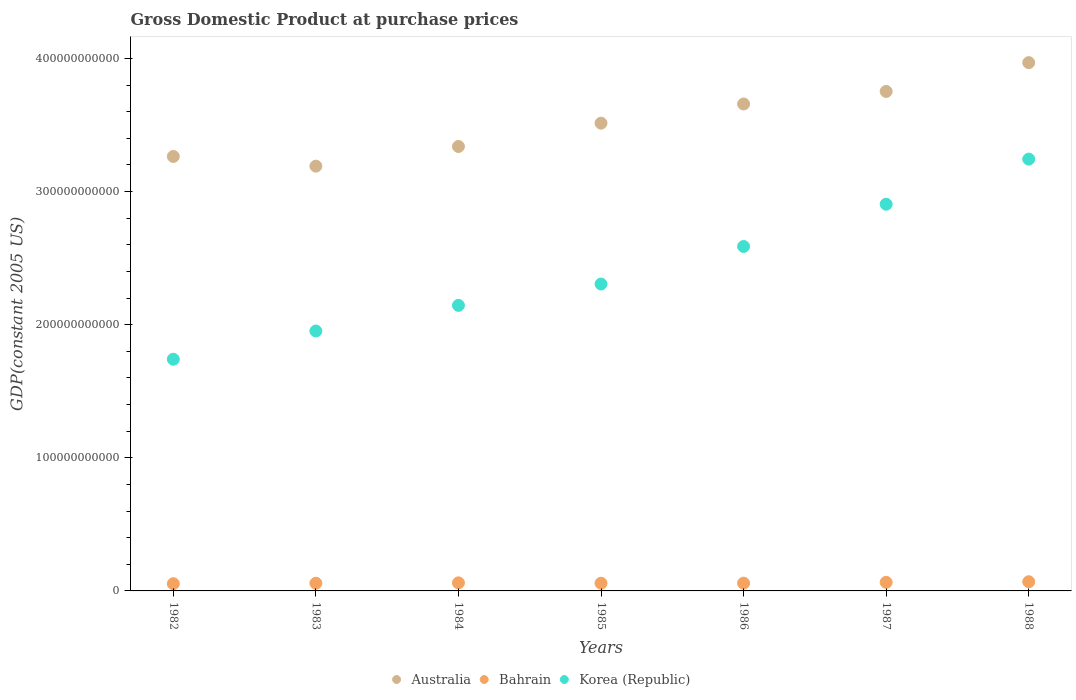Is the number of dotlines equal to the number of legend labels?
Offer a very short reply. Yes. What is the GDP at purchase prices in Australia in 1987?
Your answer should be very brief. 3.75e+11. Across all years, what is the maximum GDP at purchase prices in Australia?
Give a very brief answer. 3.97e+11. Across all years, what is the minimum GDP at purchase prices in Bahrain?
Your answer should be very brief. 5.43e+09. In which year was the GDP at purchase prices in Korea (Republic) maximum?
Keep it short and to the point. 1988. In which year was the GDP at purchase prices in Australia minimum?
Make the answer very short. 1983. What is the total GDP at purchase prices in Australia in the graph?
Your answer should be compact. 2.47e+12. What is the difference between the GDP at purchase prices in Bahrain in 1984 and that in 1988?
Provide a short and direct response. -8.39e+08. What is the difference between the GDP at purchase prices in Bahrain in 1985 and the GDP at purchase prices in Korea (Republic) in 1982?
Your answer should be very brief. -1.68e+11. What is the average GDP at purchase prices in Korea (Republic) per year?
Offer a terse response. 2.41e+11. In the year 1983, what is the difference between the GDP at purchase prices in Korea (Republic) and GDP at purchase prices in Bahrain?
Make the answer very short. 1.90e+11. What is the ratio of the GDP at purchase prices in Korea (Republic) in 1982 to that in 1985?
Your response must be concise. 0.76. Is the difference between the GDP at purchase prices in Korea (Republic) in 1983 and 1985 greater than the difference between the GDP at purchase prices in Bahrain in 1983 and 1985?
Your answer should be compact. No. What is the difference between the highest and the second highest GDP at purchase prices in Korea (Republic)?
Your response must be concise. 3.39e+1. What is the difference between the highest and the lowest GDP at purchase prices in Bahrain?
Keep it short and to the point. 1.47e+09. In how many years, is the GDP at purchase prices in Bahrain greater than the average GDP at purchase prices in Bahrain taken over all years?
Provide a succinct answer. 3. Is the sum of the GDP at purchase prices in Australia in 1987 and 1988 greater than the maximum GDP at purchase prices in Bahrain across all years?
Give a very brief answer. Yes. Does the GDP at purchase prices in Bahrain monotonically increase over the years?
Offer a terse response. No. What is the difference between two consecutive major ticks on the Y-axis?
Ensure brevity in your answer.  1.00e+11. Are the values on the major ticks of Y-axis written in scientific E-notation?
Your answer should be very brief. No. Where does the legend appear in the graph?
Your answer should be compact. Bottom center. How many legend labels are there?
Your response must be concise. 3. How are the legend labels stacked?
Offer a very short reply. Horizontal. What is the title of the graph?
Keep it short and to the point. Gross Domestic Product at purchase prices. What is the label or title of the X-axis?
Offer a terse response. Years. What is the label or title of the Y-axis?
Make the answer very short. GDP(constant 2005 US). What is the GDP(constant 2005 US) in Australia in 1982?
Offer a very short reply. 3.26e+11. What is the GDP(constant 2005 US) in Bahrain in 1982?
Your answer should be compact. 5.43e+09. What is the GDP(constant 2005 US) in Korea (Republic) in 1982?
Ensure brevity in your answer.  1.74e+11. What is the GDP(constant 2005 US) in Australia in 1983?
Ensure brevity in your answer.  3.19e+11. What is the GDP(constant 2005 US) in Bahrain in 1983?
Offer a very short reply. 5.78e+09. What is the GDP(constant 2005 US) of Korea (Republic) in 1983?
Offer a terse response. 1.95e+11. What is the GDP(constant 2005 US) in Australia in 1984?
Keep it short and to the point. 3.34e+11. What is the GDP(constant 2005 US) in Bahrain in 1984?
Give a very brief answer. 6.07e+09. What is the GDP(constant 2005 US) in Korea (Republic) in 1984?
Make the answer very short. 2.15e+11. What is the GDP(constant 2005 US) in Australia in 1985?
Your answer should be very brief. 3.51e+11. What is the GDP(constant 2005 US) in Bahrain in 1985?
Make the answer very short. 5.78e+09. What is the GDP(constant 2005 US) of Korea (Republic) in 1985?
Your answer should be very brief. 2.31e+11. What is the GDP(constant 2005 US) of Australia in 1986?
Provide a short and direct response. 3.66e+11. What is the GDP(constant 2005 US) of Bahrain in 1986?
Your answer should be very brief. 5.85e+09. What is the GDP(constant 2005 US) in Korea (Republic) in 1986?
Ensure brevity in your answer.  2.59e+11. What is the GDP(constant 2005 US) in Australia in 1987?
Give a very brief answer. 3.75e+11. What is the GDP(constant 2005 US) of Bahrain in 1987?
Offer a terse response. 6.45e+09. What is the GDP(constant 2005 US) in Korea (Republic) in 1987?
Keep it short and to the point. 2.91e+11. What is the GDP(constant 2005 US) of Australia in 1988?
Ensure brevity in your answer.  3.97e+11. What is the GDP(constant 2005 US) in Bahrain in 1988?
Keep it short and to the point. 6.91e+09. What is the GDP(constant 2005 US) of Korea (Republic) in 1988?
Keep it short and to the point. 3.24e+11. Across all years, what is the maximum GDP(constant 2005 US) in Australia?
Your answer should be compact. 3.97e+11. Across all years, what is the maximum GDP(constant 2005 US) of Bahrain?
Your answer should be compact. 6.91e+09. Across all years, what is the maximum GDP(constant 2005 US) in Korea (Republic)?
Offer a terse response. 3.24e+11. Across all years, what is the minimum GDP(constant 2005 US) in Australia?
Your answer should be compact. 3.19e+11. Across all years, what is the minimum GDP(constant 2005 US) of Bahrain?
Offer a very short reply. 5.43e+09. Across all years, what is the minimum GDP(constant 2005 US) in Korea (Republic)?
Your answer should be compact. 1.74e+11. What is the total GDP(constant 2005 US) in Australia in the graph?
Your answer should be very brief. 2.47e+12. What is the total GDP(constant 2005 US) in Bahrain in the graph?
Your answer should be compact. 4.23e+1. What is the total GDP(constant 2005 US) in Korea (Republic) in the graph?
Provide a short and direct response. 1.69e+12. What is the difference between the GDP(constant 2005 US) of Australia in 1982 and that in 1983?
Give a very brief answer. 7.28e+09. What is the difference between the GDP(constant 2005 US) of Bahrain in 1982 and that in 1983?
Offer a very short reply. -3.46e+08. What is the difference between the GDP(constant 2005 US) of Korea (Republic) in 1982 and that in 1983?
Your response must be concise. -2.12e+1. What is the difference between the GDP(constant 2005 US) of Australia in 1982 and that in 1984?
Make the answer very short. -7.49e+09. What is the difference between the GDP(constant 2005 US) in Bahrain in 1982 and that in 1984?
Keep it short and to the point. -6.35e+08. What is the difference between the GDP(constant 2005 US) in Korea (Republic) in 1982 and that in 1984?
Ensure brevity in your answer.  -4.05e+1. What is the difference between the GDP(constant 2005 US) of Australia in 1982 and that in 1985?
Offer a very short reply. -2.50e+1. What is the difference between the GDP(constant 2005 US) in Bahrain in 1982 and that in 1985?
Your answer should be compact. -3.47e+08. What is the difference between the GDP(constant 2005 US) in Korea (Republic) in 1982 and that in 1985?
Your response must be concise. -5.65e+1. What is the difference between the GDP(constant 2005 US) of Australia in 1982 and that in 1986?
Offer a very short reply. -3.94e+1. What is the difference between the GDP(constant 2005 US) of Bahrain in 1982 and that in 1986?
Give a very brief answer. -4.15e+08. What is the difference between the GDP(constant 2005 US) in Korea (Republic) in 1982 and that in 1986?
Provide a succinct answer. -8.47e+1. What is the difference between the GDP(constant 2005 US) of Australia in 1982 and that in 1987?
Your response must be concise. -4.88e+1. What is the difference between the GDP(constant 2005 US) in Bahrain in 1982 and that in 1987?
Your answer should be compact. -1.02e+09. What is the difference between the GDP(constant 2005 US) of Korea (Republic) in 1982 and that in 1987?
Your answer should be compact. -1.16e+11. What is the difference between the GDP(constant 2005 US) of Australia in 1982 and that in 1988?
Provide a short and direct response. -7.05e+1. What is the difference between the GDP(constant 2005 US) in Bahrain in 1982 and that in 1988?
Your answer should be compact. -1.47e+09. What is the difference between the GDP(constant 2005 US) of Korea (Republic) in 1982 and that in 1988?
Give a very brief answer. -1.50e+11. What is the difference between the GDP(constant 2005 US) of Australia in 1983 and that in 1984?
Make the answer very short. -1.48e+1. What is the difference between the GDP(constant 2005 US) in Bahrain in 1983 and that in 1984?
Keep it short and to the point. -2.89e+08. What is the difference between the GDP(constant 2005 US) of Korea (Republic) in 1983 and that in 1984?
Provide a succinct answer. -1.93e+1. What is the difference between the GDP(constant 2005 US) of Australia in 1983 and that in 1985?
Your answer should be very brief. -3.23e+1. What is the difference between the GDP(constant 2005 US) of Bahrain in 1983 and that in 1985?
Your answer should be compact. -4.21e+05. What is the difference between the GDP(constant 2005 US) in Korea (Republic) in 1983 and that in 1985?
Your answer should be very brief. -3.53e+1. What is the difference between the GDP(constant 2005 US) of Australia in 1983 and that in 1986?
Give a very brief answer. -4.67e+1. What is the difference between the GDP(constant 2005 US) of Bahrain in 1983 and that in 1986?
Provide a short and direct response. -6.88e+07. What is the difference between the GDP(constant 2005 US) of Korea (Republic) in 1983 and that in 1986?
Provide a succinct answer. -6.35e+1. What is the difference between the GDP(constant 2005 US) in Australia in 1983 and that in 1987?
Your answer should be compact. -5.61e+1. What is the difference between the GDP(constant 2005 US) of Bahrain in 1983 and that in 1987?
Keep it short and to the point. -6.77e+08. What is the difference between the GDP(constant 2005 US) of Korea (Republic) in 1983 and that in 1987?
Provide a short and direct response. -9.52e+1. What is the difference between the GDP(constant 2005 US) of Australia in 1983 and that in 1988?
Give a very brief answer. -7.78e+1. What is the difference between the GDP(constant 2005 US) of Bahrain in 1983 and that in 1988?
Keep it short and to the point. -1.13e+09. What is the difference between the GDP(constant 2005 US) in Korea (Republic) in 1983 and that in 1988?
Offer a very short reply. -1.29e+11. What is the difference between the GDP(constant 2005 US) of Australia in 1984 and that in 1985?
Provide a succinct answer. -1.75e+1. What is the difference between the GDP(constant 2005 US) of Bahrain in 1984 and that in 1985?
Provide a short and direct response. 2.89e+08. What is the difference between the GDP(constant 2005 US) in Korea (Republic) in 1984 and that in 1985?
Your response must be concise. -1.60e+1. What is the difference between the GDP(constant 2005 US) of Australia in 1984 and that in 1986?
Provide a succinct answer. -3.19e+1. What is the difference between the GDP(constant 2005 US) in Bahrain in 1984 and that in 1986?
Offer a terse response. 2.20e+08. What is the difference between the GDP(constant 2005 US) of Korea (Republic) in 1984 and that in 1986?
Provide a short and direct response. -4.42e+1. What is the difference between the GDP(constant 2005 US) of Australia in 1984 and that in 1987?
Ensure brevity in your answer.  -4.14e+1. What is the difference between the GDP(constant 2005 US) of Bahrain in 1984 and that in 1987?
Give a very brief answer. -3.88e+08. What is the difference between the GDP(constant 2005 US) of Korea (Republic) in 1984 and that in 1987?
Ensure brevity in your answer.  -7.60e+1. What is the difference between the GDP(constant 2005 US) of Australia in 1984 and that in 1988?
Make the answer very short. -6.30e+1. What is the difference between the GDP(constant 2005 US) in Bahrain in 1984 and that in 1988?
Provide a short and direct response. -8.39e+08. What is the difference between the GDP(constant 2005 US) of Korea (Republic) in 1984 and that in 1988?
Offer a very short reply. -1.10e+11. What is the difference between the GDP(constant 2005 US) of Australia in 1985 and that in 1986?
Your answer should be compact. -1.44e+1. What is the difference between the GDP(constant 2005 US) of Bahrain in 1985 and that in 1986?
Provide a succinct answer. -6.84e+07. What is the difference between the GDP(constant 2005 US) in Korea (Republic) in 1985 and that in 1986?
Ensure brevity in your answer.  -2.82e+1. What is the difference between the GDP(constant 2005 US) of Australia in 1985 and that in 1987?
Your answer should be very brief. -2.38e+1. What is the difference between the GDP(constant 2005 US) in Bahrain in 1985 and that in 1987?
Provide a succinct answer. -6.76e+08. What is the difference between the GDP(constant 2005 US) of Korea (Republic) in 1985 and that in 1987?
Offer a terse response. -6.00e+1. What is the difference between the GDP(constant 2005 US) of Australia in 1985 and that in 1988?
Provide a short and direct response. -4.55e+1. What is the difference between the GDP(constant 2005 US) of Bahrain in 1985 and that in 1988?
Provide a succinct answer. -1.13e+09. What is the difference between the GDP(constant 2005 US) in Korea (Republic) in 1985 and that in 1988?
Offer a terse response. -9.38e+1. What is the difference between the GDP(constant 2005 US) in Australia in 1986 and that in 1987?
Give a very brief answer. -9.42e+09. What is the difference between the GDP(constant 2005 US) in Bahrain in 1986 and that in 1987?
Give a very brief answer. -6.08e+08. What is the difference between the GDP(constant 2005 US) of Korea (Republic) in 1986 and that in 1987?
Keep it short and to the point. -3.17e+1. What is the difference between the GDP(constant 2005 US) of Australia in 1986 and that in 1988?
Your answer should be very brief. -3.11e+1. What is the difference between the GDP(constant 2005 US) in Bahrain in 1986 and that in 1988?
Make the answer very short. -1.06e+09. What is the difference between the GDP(constant 2005 US) of Korea (Republic) in 1986 and that in 1988?
Ensure brevity in your answer.  -6.56e+1. What is the difference between the GDP(constant 2005 US) in Australia in 1987 and that in 1988?
Keep it short and to the point. -2.16e+1. What is the difference between the GDP(constant 2005 US) of Bahrain in 1987 and that in 1988?
Give a very brief answer. -4.52e+08. What is the difference between the GDP(constant 2005 US) in Korea (Republic) in 1987 and that in 1988?
Give a very brief answer. -3.39e+1. What is the difference between the GDP(constant 2005 US) of Australia in 1982 and the GDP(constant 2005 US) of Bahrain in 1983?
Your response must be concise. 3.21e+11. What is the difference between the GDP(constant 2005 US) of Australia in 1982 and the GDP(constant 2005 US) of Korea (Republic) in 1983?
Give a very brief answer. 1.31e+11. What is the difference between the GDP(constant 2005 US) in Bahrain in 1982 and the GDP(constant 2005 US) in Korea (Republic) in 1983?
Your answer should be compact. -1.90e+11. What is the difference between the GDP(constant 2005 US) of Australia in 1982 and the GDP(constant 2005 US) of Bahrain in 1984?
Your answer should be compact. 3.20e+11. What is the difference between the GDP(constant 2005 US) of Australia in 1982 and the GDP(constant 2005 US) of Korea (Republic) in 1984?
Offer a terse response. 1.12e+11. What is the difference between the GDP(constant 2005 US) in Bahrain in 1982 and the GDP(constant 2005 US) in Korea (Republic) in 1984?
Your response must be concise. -2.09e+11. What is the difference between the GDP(constant 2005 US) in Australia in 1982 and the GDP(constant 2005 US) in Bahrain in 1985?
Your answer should be compact. 3.21e+11. What is the difference between the GDP(constant 2005 US) in Australia in 1982 and the GDP(constant 2005 US) in Korea (Republic) in 1985?
Make the answer very short. 9.58e+1. What is the difference between the GDP(constant 2005 US) in Bahrain in 1982 and the GDP(constant 2005 US) in Korea (Republic) in 1985?
Provide a short and direct response. -2.25e+11. What is the difference between the GDP(constant 2005 US) in Australia in 1982 and the GDP(constant 2005 US) in Bahrain in 1986?
Give a very brief answer. 3.21e+11. What is the difference between the GDP(constant 2005 US) of Australia in 1982 and the GDP(constant 2005 US) of Korea (Republic) in 1986?
Ensure brevity in your answer.  6.76e+1. What is the difference between the GDP(constant 2005 US) of Bahrain in 1982 and the GDP(constant 2005 US) of Korea (Republic) in 1986?
Offer a terse response. -2.53e+11. What is the difference between the GDP(constant 2005 US) in Australia in 1982 and the GDP(constant 2005 US) in Bahrain in 1987?
Keep it short and to the point. 3.20e+11. What is the difference between the GDP(constant 2005 US) in Australia in 1982 and the GDP(constant 2005 US) in Korea (Republic) in 1987?
Your answer should be compact. 3.59e+1. What is the difference between the GDP(constant 2005 US) of Bahrain in 1982 and the GDP(constant 2005 US) of Korea (Republic) in 1987?
Your response must be concise. -2.85e+11. What is the difference between the GDP(constant 2005 US) of Australia in 1982 and the GDP(constant 2005 US) of Bahrain in 1988?
Give a very brief answer. 3.19e+11. What is the difference between the GDP(constant 2005 US) of Australia in 1982 and the GDP(constant 2005 US) of Korea (Republic) in 1988?
Give a very brief answer. 2.01e+09. What is the difference between the GDP(constant 2005 US) in Bahrain in 1982 and the GDP(constant 2005 US) in Korea (Republic) in 1988?
Offer a terse response. -3.19e+11. What is the difference between the GDP(constant 2005 US) in Australia in 1983 and the GDP(constant 2005 US) in Bahrain in 1984?
Your response must be concise. 3.13e+11. What is the difference between the GDP(constant 2005 US) of Australia in 1983 and the GDP(constant 2005 US) of Korea (Republic) in 1984?
Make the answer very short. 1.05e+11. What is the difference between the GDP(constant 2005 US) in Bahrain in 1983 and the GDP(constant 2005 US) in Korea (Republic) in 1984?
Make the answer very short. -2.09e+11. What is the difference between the GDP(constant 2005 US) of Australia in 1983 and the GDP(constant 2005 US) of Bahrain in 1985?
Your response must be concise. 3.13e+11. What is the difference between the GDP(constant 2005 US) in Australia in 1983 and the GDP(constant 2005 US) in Korea (Republic) in 1985?
Offer a terse response. 8.86e+1. What is the difference between the GDP(constant 2005 US) in Bahrain in 1983 and the GDP(constant 2005 US) in Korea (Republic) in 1985?
Offer a very short reply. -2.25e+11. What is the difference between the GDP(constant 2005 US) of Australia in 1983 and the GDP(constant 2005 US) of Bahrain in 1986?
Offer a very short reply. 3.13e+11. What is the difference between the GDP(constant 2005 US) in Australia in 1983 and the GDP(constant 2005 US) in Korea (Republic) in 1986?
Offer a terse response. 6.03e+1. What is the difference between the GDP(constant 2005 US) of Bahrain in 1983 and the GDP(constant 2005 US) of Korea (Republic) in 1986?
Provide a short and direct response. -2.53e+11. What is the difference between the GDP(constant 2005 US) of Australia in 1983 and the GDP(constant 2005 US) of Bahrain in 1987?
Offer a terse response. 3.13e+11. What is the difference between the GDP(constant 2005 US) of Australia in 1983 and the GDP(constant 2005 US) of Korea (Republic) in 1987?
Ensure brevity in your answer.  2.86e+1. What is the difference between the GDP(constant 2005 US) in Bahrain in 1983 and the GDP(constant 2005 US) in Korea (Republic) in 1987?
Give a very brief answer. -2.85e+11. What is the difference between the GDP(constant 2005 US) of Australia in 1983 and the GDP(constant 2005 US) of Bahrain in 1988?
Offer a terse response. 3.12e+11. What is the difference between the GDP(constant 2005 US) of Australia in 1983 and the GDP(constant 2005 US) of Korea (Republic) in 1988?
Offer a very short reply. -5.27e+09. What is the difference between the GDP(constant 2005 US) in Bahrain in 1983 and the GDP(constant 2005 US) in Korea (Republic) in 1988?
Your answer should be compact. -3.19e+11. What is the difference between the GDP(constant 2005 US) of Australia in 1984 and the GDP(constant 2005 US) of Bahrain in 1985?
Offer a terse response. 3.28e+11. What is the difference between the GDP(constant 2005 US) in Australia in 1984 and the GDP(constant 2005 US) in Korea (Republic) in 1985?
Make the answer very short. 1.03e+11. What is the difference between the GDP(constant 2005 US) of Bahrain in 1984 and the GDP(constant 2005 US) of Korea (Republic) in 1985?
Ensure brevity in your answer.  -2.24e+11. What is the difference between the GDP(constant 2005 US) of Australia in 1984 and the GDP(constant 2005 US) of Bahrain in 1986?
Your response must be concise. 3.28e+11. What is the difference between the GDP(constant 2005 US) in Australia in 1984 and the GDP(constant 2005 US) in Korea (Republic) in 1986?
Your response must be concise. 7.51e+1. What is the difference between the GDP(constant 2005 US) of Bahrain in 1984 and the GDP(constant 2005 US) of Korea (Republic) in 1986?
Make the answer very short. -2.53e+11. What is the difference between the GDP(constant 2005 US) of Australia in 1984 and the GDP(constant 2005 US) of Bahrain in 1987?
Your answer should be very brief. 3.27e+11. What is the difference between the GDP(constant 2005 US) in Australia in 1984 and the GDP(constant 2005 US) in Korea (Republic) in 1987?
Make the answer very short. 4.34e+1. What is the difference between the GDP(constant 2005 US) in Bahrain in 1984 and the GDP(constant 2005 US) in Korea (Republic) in 1987?
Your answer should be compact. -2.84e+11. What is the difference between the GDP(constant 2005 US) in Australia in 1984 and the GDP(constant 2005 US) in Bahrain in 1988?
Keep it short and to the point. 3.27e+11. What is the difference between the GDP(constant 2005 US) of Australia in 1984 and the GDP(constant 2005 US) of Korea (Republic) in 1988?
Provide a short and direct response. 9.49e+09. What is the difference between the GDP(constant 2005 US) of Bahrain in 1984 and the GDP(constant 2005 US) of Korea (Republic) in 1988?
Make the answer very short. -3.18e+11. What is the difference between the GDP(constant 2005 US) in Australia in 1985 and the GDP(constant 2005 US) in Bahrain in 1986?
Keep it short and to the point. 3.46e+11. What is the difference between the GDP(constant 2005 US) in Australia in 1985 and the GDP(constant 2005 US) in Korea (Republic) in 1986?
Keep it short and to the point. 9.26e+1. What is the difference between the GDP(constant 2005 US) in Bahrain in 1985 and the GDP(constant 2005 US) in Korea (Republic) in 1986?
Your answer should be compact. -2.53e+11. What is the difference between the GDP(constant 2005 US) of Australia in 1985 and the GDP(constant 2005 US) of Bahrain in 1987?
Provide a short and direct response. 3.45e+11. What is the difference between the GDP(constant 2005 US) of Australia in 1985 and the GDP(constant 2005 US) of Korea (Republic) in 1987?
Your answer should be compact. 6.09e+1. What is the difference between the GDP(constant 2005 US) in Bahrain in 1985 and the GDP(constant 2005 US) in Korea (Republic) in 1987?
Provide a succinct answer. -2.85e+11. What is the difference between the GDP(constant 2005 US) of Australia in 1985 and the GDP(constant 2005 US) of Bahrain in 1988?
Provide a short and direct response. 3.45e+11. What is the difference between the GDP(constant 2005 US) of Australia in 1985 and the GDP(constant 2005 US) of Korea (Republic) in 1988?
Your response must be concise. 2.70e+1. What is the difference between the GDP(constant 2005 US) of Bahrain in 1985 and the GDP(constant 2005 US) of Korea (Republic) in 1988?
Make the answer very short. -3.19e+11. What is the difference between the GDP(constant 2005 US) of Australia in 1986 and the GDP(constant 2005 US) of Bahrain in 1987?
Offer a very short reply. 3.59e+11. What is the difference between the GDP(constant 2005 US) of Australia in 1986 and the GDP(constant 2005 US) of Korea (Republic) in 1987?
Ensure brevity in your answer.  7.53e+1. What is the difference between the GDP(constant 2005 US) in Bahrain in 1986 and the GDP(constant 2005 US) in Korea (Republic) in 1987?
Keep it short and to the point. -2.85e+11. What is the difference between the GDP(constant 2005 US) in Australia in 1986 and the GDP(constant 2005 US) in Bahrain in 1988?
Offer a terse response. 3.59e+11. What is the difference between the GDP(constant 2005 US) in Australia in 1986 and the GDP(constant 2005 US) in Korea (Republic) in 1988?
Make the answer very short. 4.14e+1. What is the difference between the GDP(constant 2005 US) in Bahrain in 1986 and the GDP(constant 2005 US) in Korea (Republic) in 1988?
Offer a very short reply. -3.19e+11. What is the difference between the GDP(constant 2005 US) in Australia in 1987 and the GDP(constant 2005 US) in Bahrain in 1988?
Ensure brevity in your answer.  3.68e+11. What is the difference between the GDP(constant 2005 US) of Australia in 1987 and the GDP(constant 2005 US) of Korea (Republic) in 1988?
Keep it short and to the point. 5.09e+1. What is the difference between the GDP(constant 2005 US) of Bahrain in 1987 and the GDP(constant 2005 US) of Korea (Republic) in 1988?
Give a very brief answer. -3.18e+11. What is the average GDP(constant 2005 US) in Australia per year?
Offer a terse response. 3.53e+11. What is the average GDP(constant 2005 US) in Bahrain per year?
Keep it short and to the point. 6.04e+09. What is the average GDP(constant 2005 US) in Korea (Republic) per year?
Offer a very short reply. 2.41e+11. In the year 1982, what is the difference between the GDP(constant 2005 US) in Australia and GDP(constant 2005 US) in Bahrain?
Your response must be concise. 3.21e+11. In the year 1982, what is the difference between the GDP(constant 2005 US) of Australia and GDP(constant 2005 US) of Korea (Republic)?
Make the answer very short. 1.52e+11. In the year 1982, what is the difference between the GDP(constant 2005 US) in Bahrain and GDP(constant 2005 US) in Korea (Republic)?
Provide a succinct answer. -1.69e+11. In the year 1983, what is the difference between the GDP(constant 2005 US) of Australia and GDP(constant 2005 US) of Bahrain?
Provide a short and direct response. 3.13e+11. In the year 1983, what is the difference between the GDP(constant 2005 US) in Australia and GDP(constant 2005 US) in Korea (Republic)?
Make the answer very short. 1.24e+11. In the year 1983, what is the difference between the GDP(constant 2005 US) in Bahrain and GDP(constant 2005 US) in Korea (Republic)?
Provide a short and direct response. -1.90e+11. In the year 1984, what is the difference between the GDP(constant 2005 US) of Australia and GDP(constant 2005 US) of Bahrain?
Your answer should be compact. 3.28e+11. In the year 1984, what is the difference between the GDP(constant 2005 US) of Australia and GDP(constant 2005 US) of Korea (Republic)?
Your response must be concise. 1.19e+11. In the year 1984, what is the difference between the GDP(constant 2005 US) of Bahrain and GDP(constant 2005 US) of Korea (Republic)?
Your answer should be very brief. -2.08e+11. In the year 1985, what is the difference between the GDP(constant 2005 US) in Australia and GDP(constant 2005 US) in Bahrain?
Your answer should be compact. 3.46e+11. In the year 1985, what is the difference between the GDP(constant 2005 US) of Australia and GDP(constant 2005 US) of Korea (Republic)?
Offer a very short reply. 1.21e+11. In the year 1985, what is the difference between the GDP(constant 2005 US) of Bahrain and GDP(constant 2005 US) of Korea (Republic)?
Give a very brief answer. -2.25e+11. In the year 1986, what is the difference between the GDP(constant 2005 US) of Australia and GDP(constant 2005 US) of Bahrain?
Provide a short and direct response. 3.60e+11. In the year 1986, what is the difference between the GDP(constant 2005 US) of Australia and GDP(constant 2005 US) of Korea (Republic)?
Offer a very short reply. 1.07e+11. In the year 1986, what is the difference between the GDP(constant 2005 US) of Bahrain and GDP(constant 2005 US) of Korea (Republic)?
Ensure brevity in your answer.  -2.53e+11. In the year 1987, what is the difference between the GDP(constant 2005 US) of Australia and GDP(constant 2005 US) of Bahrain?
Your answer should be very brief. 3.69e+11. In the year 1987, what is the difference between the GDP(constant 2005 US) of Australia and GDP(constant 2005 US) of Korea (Republic)?
Make the answer very short. 8.47e+1. In the year 1987, what is the difference between the GDP(constant 2005 US) of Bahrain and GDP(constant 2005 US) of Korea (Republic)?
Keep it short and to the point. -2.84e+11. In the year 1988, what is the difference between the GDP(constant 2005 US) in Australia and GDP(constant 2005 US) in Bahrain?
Your answer should be compact. 3.90e+11. In the year 1988, what is the difference between the GDP(constant 2005 US) of Australia and GDP(constant 2005 US) of Korea (Republic)?
Offer a very short reply. 7.25e+1. In the year 1988, what is the difference between the GDP(constant 2005 US) of Bahrain and GDP(constant 2005 US) of Korea (Republic)?
Your response must be concise. -3.17e+11. What is the ratio of the GDP(constant 2005 US) in Australia in 1982 to that in 1983?
Offer a terse response. 1.02. What is the ratio of the GDP(constant 2005 US) of Bahrain in 1982 to that in 1983?
Provide a short and direct response. 0.94. What is the ratio of the GDP(constant 2005 US) of Korea (Republic) in 1982 to that in 1983?
Make the answer very short. 0.89. What is the ratio of the GDP(constant 2005 US) of Australia in 1982 to that in 1984?
Provide a succinct answer. 0.98. What is the ratio of the GDP(constant 2005 US) in Bahrain in 1982 to that in 1984?
Your answer should be very brief. 0.9. What is the ratio of the GDP(constant 2005 US) in Korea (Republic) in 1982 to that in 1984?
Provide a succinct answer. 0.81. What is the ratio of the GDP(constant 2005 US) in Australia in 1982 to that in 1985?
Your response must be concise. 0.93. What is the ratio of the GDP(constant 2005 US) of Bahrain in 1982 to that in 1985?
Ensure brevity in your answer.  0.94. What is the ratio of the GDP(constant 2005 US) in Korea (Republic) in 1982 to that in 1985?
Provide a short and direct response. 0.76. What is the ratio of the GDP(constant 2005 US) in Australia in 1982 to that in 1986?
Your answer should be very brief. 0.89. What is the ratio of the GDP(constant 2005 US) in Bahrain in 1982 to that in 1986?
Offer a terse response. 0.93. What is the ratio of the GDP(constant 2005 US) in Korea (Republic) in 1982 to that in 1986?
Ensure brevity in your answer.  0.67. What is the ratio of the GDP(constant 2005 US) in Australia in 1982 to that in 1987?
Make the answer very short. 0.87. What is the ratio of the GDP(constant 2005 US) of Bahrain in 1982 to that in 1987?
Your response must be concise. 0.84. What is the ratio of the GDP(constant 2005 US) in Korea (Republic) in 1982 to that in 1987?
Offer a very short reply. 0.6. What is the ratio of the GDP(constant 2005 US) in Australia in 1982 to that in 1988?
Your answer should be very brief. 0.82. What is the ratio of the GDP(constant 2005 US) of Bahrain in 1982 to that in 1988?
Provide a short and direct response. 0.79. What is the ratio of the GDP(constant 2005 US) of Korea (Republic) in 1982 to that in 1988?
Ensure brevity in your answer.  0.54. What is the ratio of the GDP(constant 2005 US) in Australia in 1983 to that in 1984?
Provide a succinct answer. 0.96. What is the ratio of the GDP(constant 2005 US) of Bahrain in 1983 to that in 1984?
Keep it short and to the point. 0.95. What is the ratio of the GDP(constant 2005 US) of Korea (Republic) in 1983 to that in 1984?
Ensure brevity in your answer.  0.91. What is the ratio of the GDP(constant 2005 US) in Australia in 1983 to that in 1985?
Keep it short and to the point. 0.91. What is the ratio of the GDP(constant 2005 US) of Bahrain in 1983 to that in 1985?
Provide a short and direct response. 1. What is the ratio of the GDP(constant 2005 US) of Korea (Republic) in 1983 to that in 1985?
Provide a short and direct response. 0.85. What is the ratio of the GDP(constant 2005 US) in Australia in 1983 to that in 1986?
Offer a very short reply. 0.87. What is the ratio of the GDP(constant 2005 US) of Korea (Republic) in 1983 to that in 1986?
Offer a very short reply. 0.75. What is the ratio of the GDP(constant 2005 US) in Australia in 1983 to that in 1987?
Your answer should be compact. 0.85. What is the ratio of the GDP(constant 2005 US) in Bahrain in 1983 to that in 1987?
Give a very brief answer. 0.9. What is the ratio of the GDP(constant 2005 US) of Korea (Republic) in 1983 to that in 1987?
Provide a short and direct response. 0.67. What is the ratio of the GDP(constant 2005 US) in Australia in 1983 to that in 1988?
Provide a short and direct response. 0.8. What is the ratio of the GDP(constant 2005 US) in Bahrain in 1983 to that in 1988?
Offer a very short reply. 0.84. What is the ratio of the GDP(constant 2005 US) of Korea (Republic) in 1983 to that in 1988?
Your answer should be compact. 0.6. What is the ratio of the GDP(constant 2005 US) in Australia in 1984 to that in 1985?
Provide a short and direct response. 0.95. What is the ratio of the GDP(constant 2005 US) in Bahrain in 1984 to that in 1985?
Ensure brevity in your answer.  1.05. What is the ratio of the GDP(constant 2005 US) in Korea (Republic) in 1984 to that in 1985?
Give a very brief answer. 0.93. What is the ratio of the GDP(constant 2005 US) in Australia in 1984 to that in 1986?
Make the answer very short. 0.91. What is the ratio of the GDP(constant 2005 US) of Bahrain in 1984 to that in 1986?
Provide a succinct answer. 1.04. What is the ratio of the GDP(constant 2005 US) of Korea (Republic) in 1984 to that in 1986?
Your answer should be very brief. 0.83. What is the ratio of the GDP(constant 2005 US) of Australia in 1984 to that in 1987?
Give a very brief answer. 0.89. What is the ratio of the GDP(constant 2005 US) in Bahrain in 1984 to that in 1987?
Provide a succinct answer. 0.94. What is the ratio of the GDP(constant 2005 US) in Korea (Republic) in 1984 to that in 1987?
Provide a succinct answer. 0.74. What is the ratio of the GDP(constant 2005 US) of Australia in 1984 to that in 1988?
Offer a very short reply. 0.84. What is the ratio of the GDP(constant 2005 US) in Bahrain in 1984 to that in 1988?
Your response must be concise. 0.88. What is the ratio of the GDP(constant 2005 US) of Korea (Republic) in 1984 to that in 1988?
Make the answer very short. 0.66. What is the ratio of the GDP(constant 2005 US) in Australia in 1985 to that in 1986?
Offer a terse response. 0.96. What is the ratio of the GDP(constant 2005 US) of Bahrain in 1985 to that in 1986?
Keep it short and to the point. 0.99. What is the ratio of the GDP(constant 2005 US) of Korea (Republic) in 1985 to that in 1986?
Ensure brevity in your answer.  0.89. What is the ratio of the GDP(constant 2005 US) of Australia in 1985 to that in 1987?
Provide a short and direct response. 0.94. What is the ratio of the GDP(constant 2005 US) of Bahrain in 1985 to that in 1987?
Make the answer very short. 0.9. What is the ratio of the GDP(constant 2005 US) of Korea (Republic) in 1985 to that in 1987?
Provide a short and direct response. 0.79. What is the ratio of the GDP(constant 2005 US) of Australia in 1985 to that in 1988?
Make the answer very short. 0.89. What is the ratio of the GDP(constant 2005 US) in Bahrain in 1985 to that in 1988?
Ensure brevity in your answer.  0.84. What is the ratio of the GDP(constant 2005 US) in Korea (Republic) in 1985 to that in 1988?
Offer a very short reply. 0.71. What is the ratio of the GDP(constant 2005 US) of Australia in 1986 to that in 1987?
Your answer should be very brief. 0.97. What is the ratio of the GDP(constant 2005 US) of Bahrain in 1986 to that in 1987?
Ensure brevity in your answer.  0.91. What is the ratio of the GDP(constant 2005 US) in Korea (Republic) in 1986 to that in 1987?
Give a very brief answer. 0.89. What is the ratio of the GDP(constant 2005 US) of Australia in 1986 to that in 1988?
Your answer should be very brief. 0.92. What is the ratio of the GDP(constant 2005 US) in Bahrain in 1986 to that in 1988?
Ensure brevity in your answer.  0.85. What is the ratio of the GDP(constant 2005 US) in Korea (Republic) in 1986 to that in 1988?
Your response must be concise. 0.8. What is the ratio of the GDP(constant 2005 US) of Australia in 1987 to that in 1988?
Your answer should be compact. 0.95. What is the ratio of the GDP(constant 2005 US) of Bahrain in 1987 to that in 1988?
Your response must be concise. 0.93. What is the ratio of the GDP(constant 2005 US) of Korea (Republic) in 1987 to that in 1988?
Provide a succinct answer. 0.9. What is the difference between the highest and the second highest GDP(constant 2005 US) in Australia?
Offer a very short reply. 2.16e+1. What is the difference between the highest and the second highest GDP(constant 2005 US) in Bahrain?
Give a very brief answer. 4.52e+08. What is the difference between the highest and the second highest GDP(constant 2005 US) in Korea (Republic)?
Offer a terse response. 3.39e+1. What is the difference between the highest and the lowest GDP(constant 2005 US) in Australia?
Your answer should be compact. 7.78e+1. What is the difference between the highest and the lowest GDP(constant 2005 US) of Bahrain?
Ensure brevity in your answer.  1.47e+09. What is the difference between the highest and the lowest GDP(constant 2005 US) of Korea (Republic)?
Your answer should be very brief. 1.50e+11. 